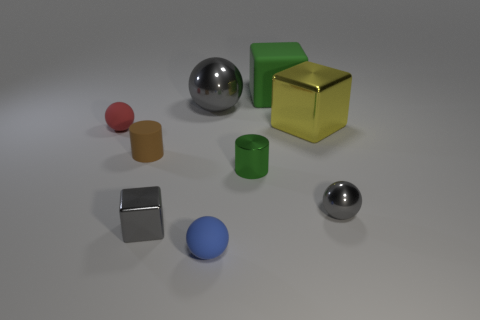There is another metallic object that is the same shape as the yellow thing; what is its color?
Ensure brevity in your answer.  Gray. What number of things are things that are behind the blue ball or gray metallic spheres in front of the small brown cylinder?
Make the answer very short. 8. Is there anything else that is the same color as the big metallic block?
Offer a terse response. No. Is the number of gray spheres on the left side of the large yellow cube the same as the number of tiny gray objects to the left of the small red rubber ball?
Offer a very short reply. No. Are there more metallic cylinders that are in front of the blue rubber sphere than yellow metal blocks?
Give a very brief answer. No. What number of things are objects to the right of the brown matte thing or metallic objects?
Keep it short and to the point. 7. How many tiny objects have the same material as the tiny gray block?
Provide a short and direct response. 2. The large object that is the same color as the tiny shiny cube is what shape?
Provide a short and direct response. Sphere. Are there any other tiny blue things that have the same shape as the blue object?
Offer a terse response. No. There is a green metal thing that is the same size as the blue ball; what shape is it?
Provide a succinct answer. Cylinder. 